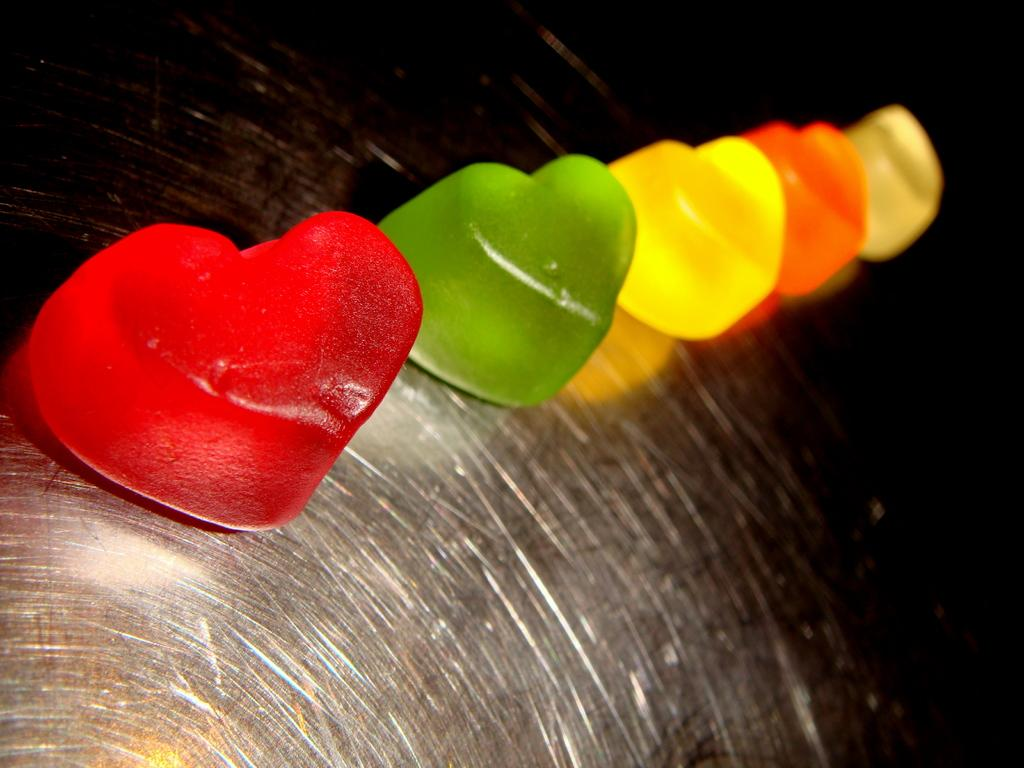What is the main subject of the image? The main subject of the image is different types of jellies. Where are the jellies located in the image? The jellies are in the center of the image. Can you describe anything else visible in the image? There is a bowl in the background of the image. How many goldfish are swimming in the bowl in the image? There are no goldfish present in the image; it only features different types of jellies and a bowl in the background. 